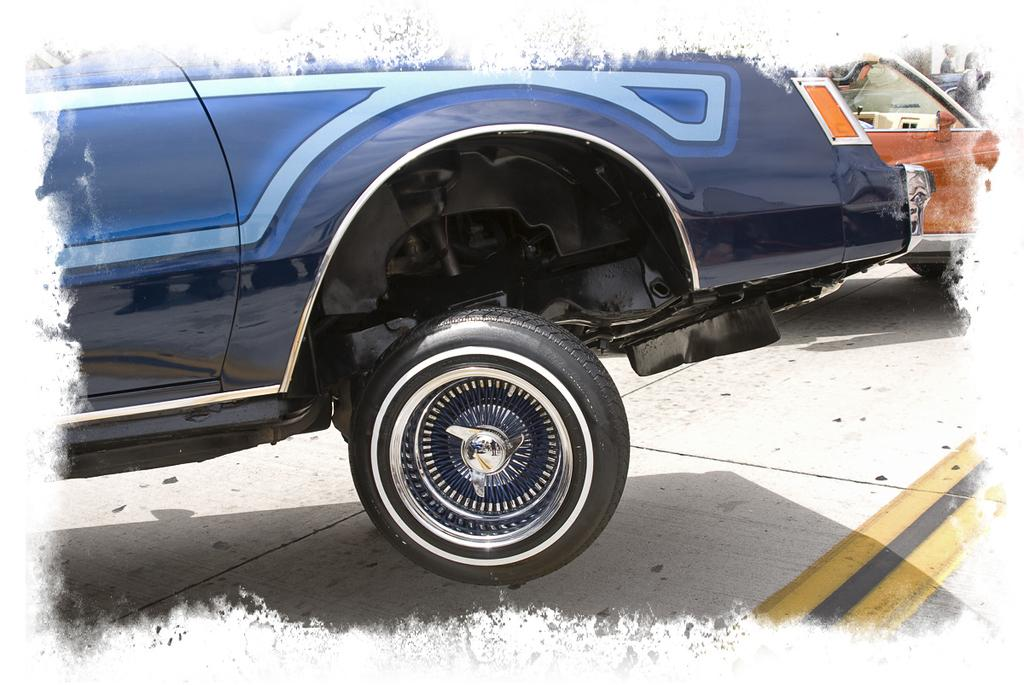What can be seen on the road in the image? There are vehicles on the road in the image. Where are the two persons located in the image? The two persons are on the right side at the top corner of the image. How has the image been modified? The image has an edited frame. What type of fruit can be seen hanging from the trees in the image? There are no trees or fruit present in the image. What instruction is given to the vehicles on the road in the image? There is no indication of any instructions or stop signs for the vehicles in the image. 